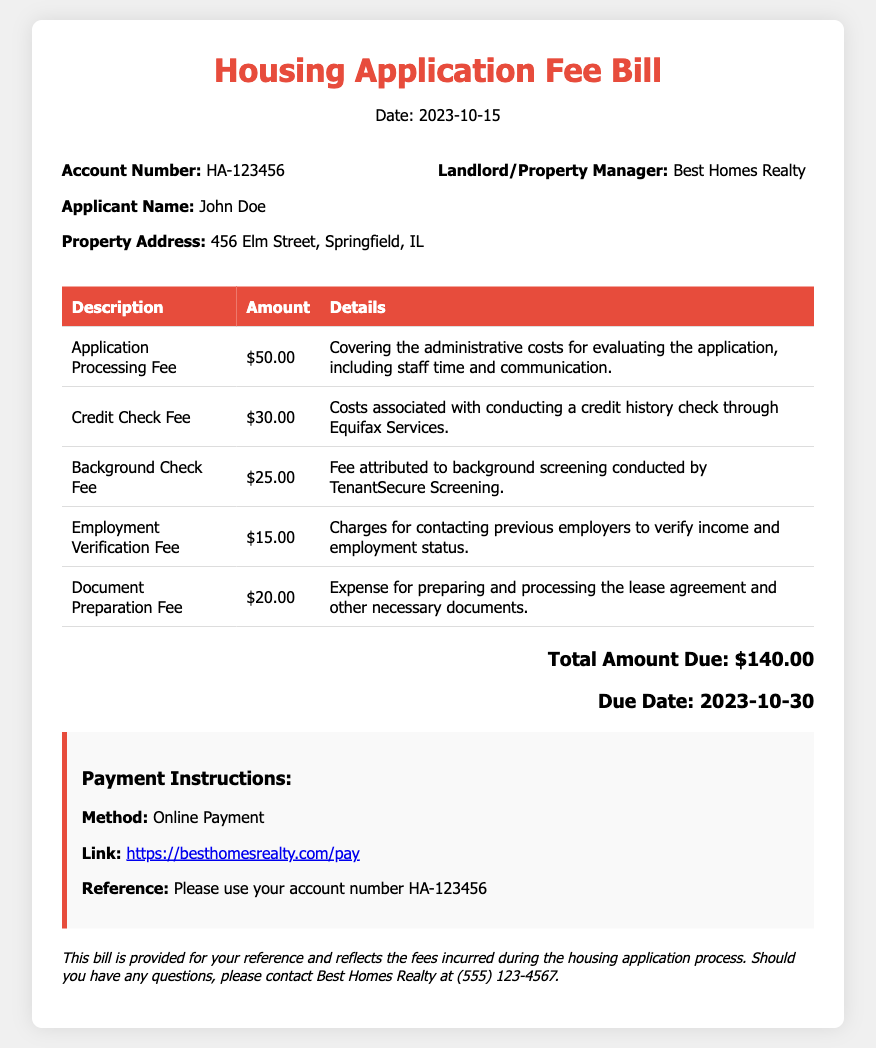What is the total amount due? The total amount due is the sum of all the fees listed in the document, which is $140.00.
Answer: $140.00 What is the applicant's name? The applicant's name is mentioned in the applicant info section of the document as John Doe.
Answer: John Doe When is the due date for the payment? The due date for the payment is specified in the total section, which is October 30, 2023.
Answer: 2023-10-30 What is the credit check fee? The credit check fee is listed in the table of fees as $30.00.
Answer: $30.00 Who conducted the background screening? The background screening was conducted by TenantSecure Screening, as stated in the details of the background check fee.
Answer: TenantSecure Screening What method of payment is mentioned in the document? The payment method described in the payment instructions is online payment.
Answer: Online Payment What is the total number of fees listed in the document? The total number of fees can be counted from the fees table, which shows five different fee descriptions.
Answer: 5 What is the description of the last fee? The last fee listed in the table is for Document Preparation Fee, which is noted in the description column.
Answer: Document Preparation Fee What is the fee for Employment Verification? The Employment Verification Fee is specified in the document as $15.00.
Answer: $15.00 